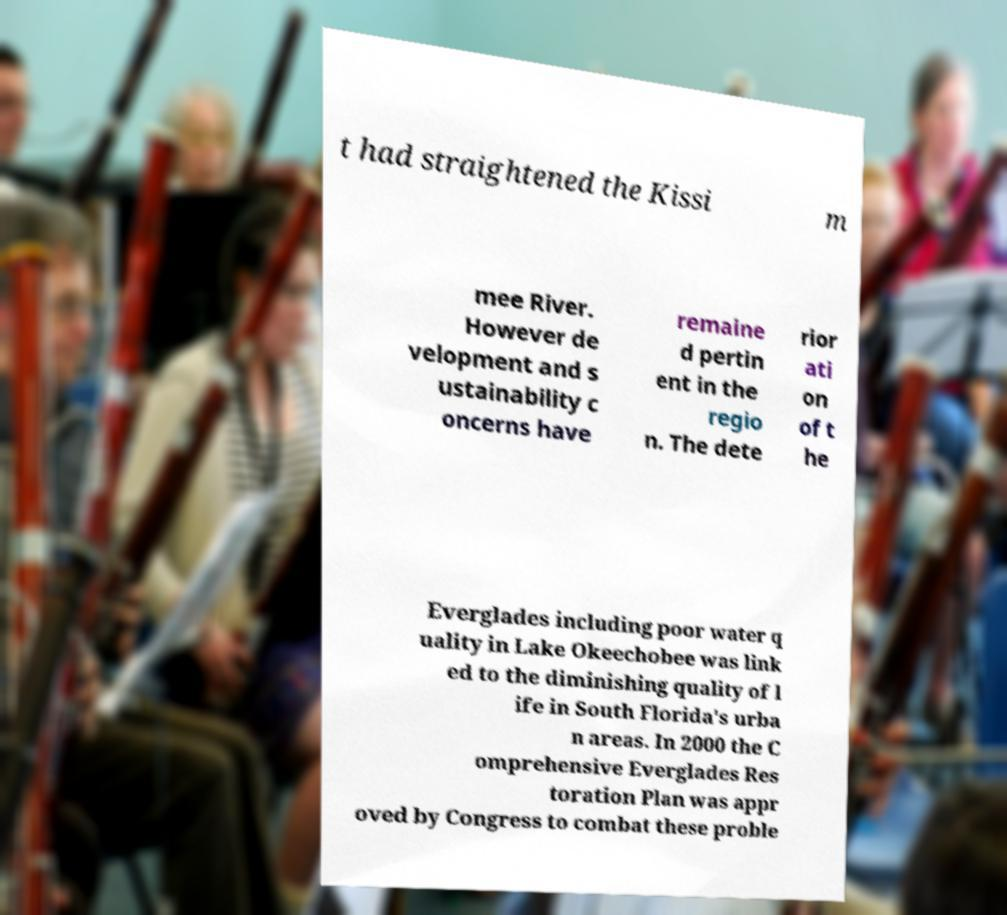Please read and relay the text visible in this image. What does it say? t had straightened the Kissi m mee River. However de velopment and s ustainability c oncerns have remaine d pertin ent in the regio n. The dete rior ati on of t he Everglades including poor water q uality in Lake Okeechobee was link ed to the diminishing quality of l ife in South Florida's urba n areas. In 2000 the C omprehensive Everglades Res toration Plan was appr oved by Congress to combat these proble 